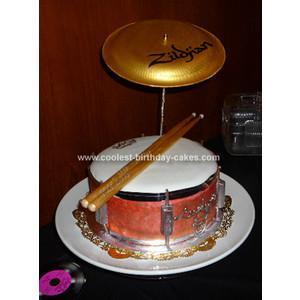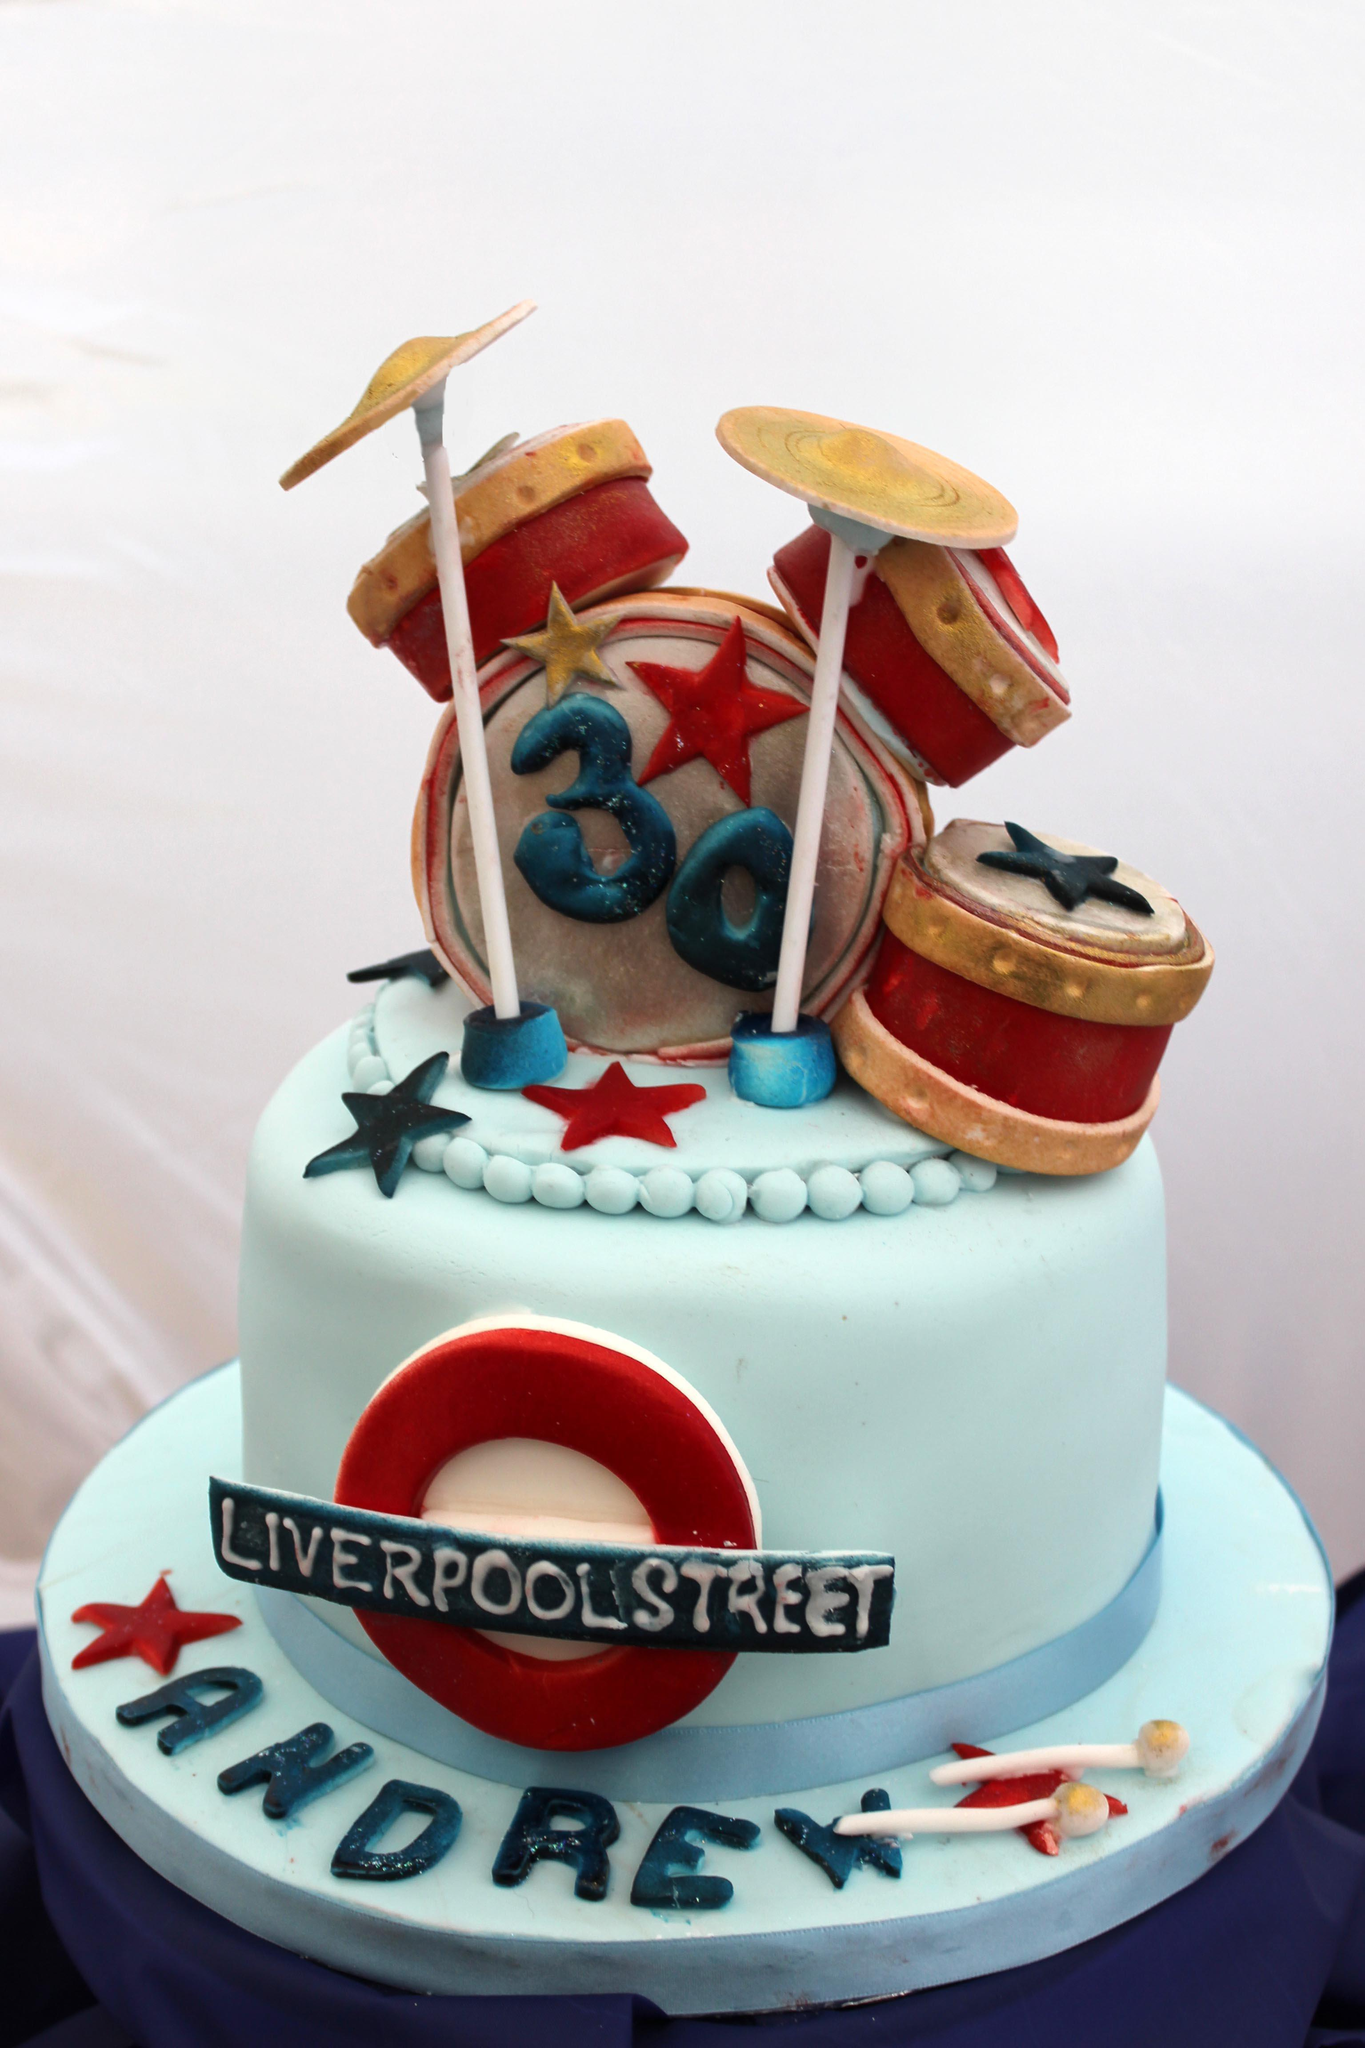The first image is the image on the left, the second image is the image on the right. Considering the images on both sides, is "One cake features a drum kit on the top, and the other cake features drum sticks on top of the base layer of the cake." valid? Answer yes or no. Yes. The first image is the image on the left, the second image is the image on the right. Analyze the images presented: Is the assertion "Both cakes are tiered." valid? Answer yes or no. No. 